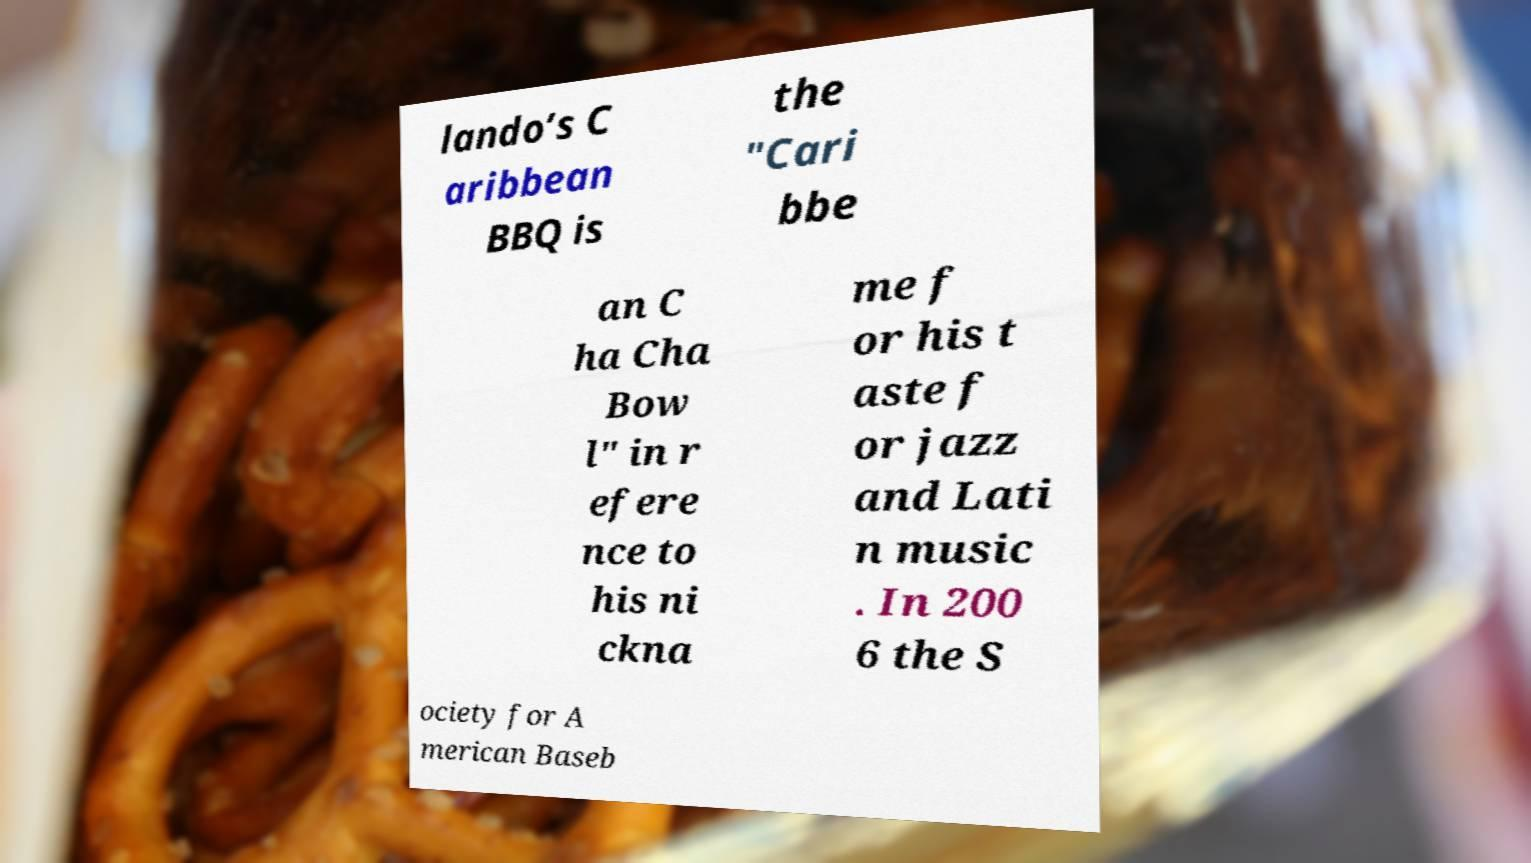Could you assist in decoding the text presented in this image and type it out clearly? lando’s C aribbean BBQ is the "Cari bbe an C ha Cha Bow l" in r efere nce to his ni ckna me f or his t aste f or jazz and Lati n music . In 200 6 the S ociety for A merican Baseb 